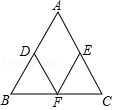What are the properties of triangle ABC in the provided diagram? Triangle ABC is an isosceles triangle as indicated by the equal sides AB and AC. As a result, angles BAB and BAC are also equal. Midpoints D, E, and F create line segments that bisect each other and form smaller congruent triangles within triangle ABC, which maintain the same angles as the larger triangle. 